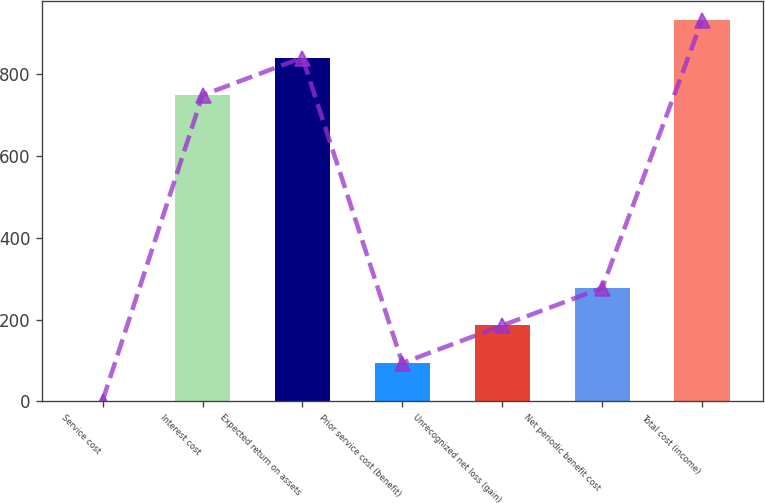Convert chart. <chart><loc_0><loc_0><loc_500><loc_500><bar_chart><fcel>Service cost<fcel>Interest cost<fcel>Expected return on assets<fcel>Prior service cost (benefit)<fcel>Unrecognized net loss (gain)<fcel>Net periodic benefit cost<fcel>Total cost (income)<nl><fcel>2<fcel>749<fcel>840.9<fcel>93.9<fcel>185.8<fcel>277.7<fcel>932.8<nl></chart> 